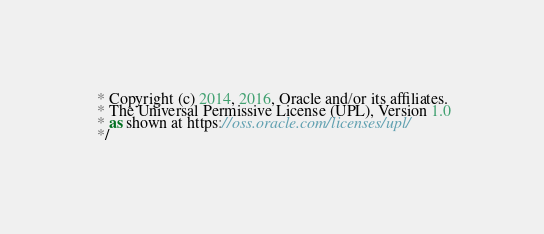Convert code to text. <code><loc_0><loc_0><loc_500><loc_500><_JavaScript_> * Copyright (c) 2014, 2016, Oracle and/or its affiliates.
 * The Universal Permissive License (UPL), Version 1.0
 * as shown at https://oss.oracle.com/licenses/upl/
 */</code> 